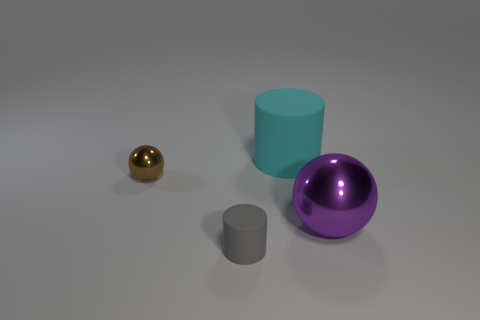What shape is the other thing that is the same material as the large purple object?
Your response must be concise. Sphere. Is the purple object made of the same material as the cyan cylinder?
Your answer should be compact. No. Are there fewer things that are left of the brown object than purple spheres in front of the large purple shiny sphere?
Give a very brief answer. No. How many balls are in front of the metal ball left of the matte cylinder on the left side of the big cyan object?
Give a very brief answer. 1. Is there another rubber object that has the same color as the big matte thing?
Provide a short and direct response. No. The matte cylinder that is the same size as the purple thing is what color?
Provide a short and direct response. Cyan. Are there any other tiny things that have the same shape as the cyan thing?
Provide a succinct answer. Yes. Is there a object that is on the right side of the rubber cylinder that is in front of the shiny object that is left of the large cyan matte cylinder?
Provide a short and direct response. Yes. There is a matte object that is the same size as the purple shiny object; what shape is it?
Keep it short and to the point. Cylinder. What is the color of the other thing that is the same shape as the large cyan thing?
Your answer should be very brief. Gray. 